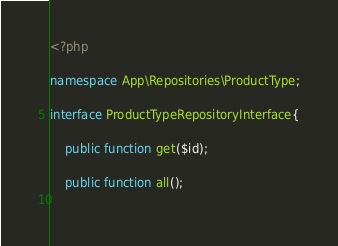Convert code to text. <code><loc_0><loc_0><loc_500><loc_500><_PHP_><?php 

namespace App\Repositories\ProductType;

interface ProductTypeRepositoryInterface{

    public function get($id);

    public function all();
    </code> 